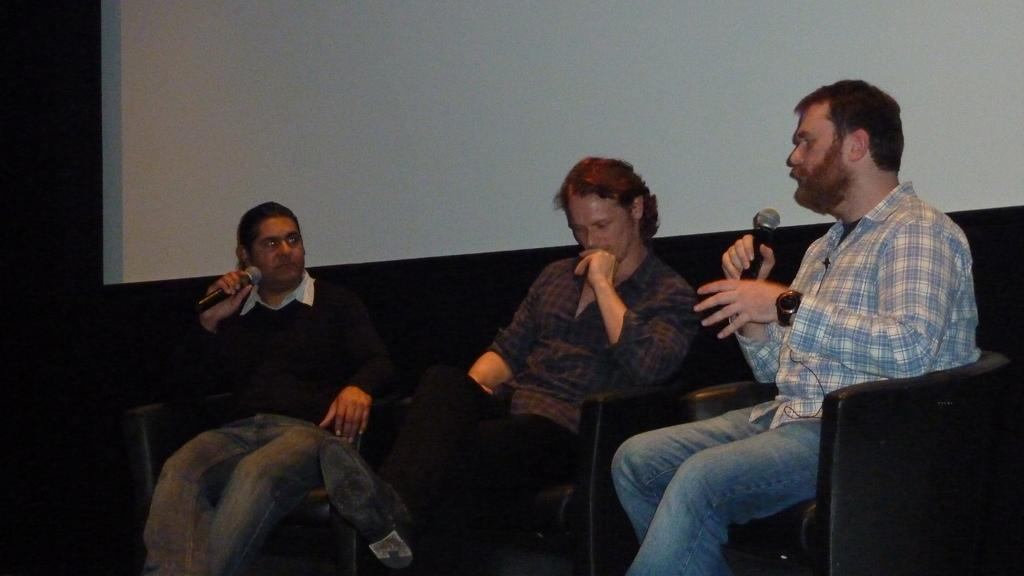What are the people in the image doing? The people in the image are sitting on sofas. Can you describe any specific actions being performed by the people? Two people are holding microphones. What can be seen in the background of the image? There is a white colored object in the background. What type of silver basket is being used by the judge in the image? There is no judge or silver basket present in the image. 